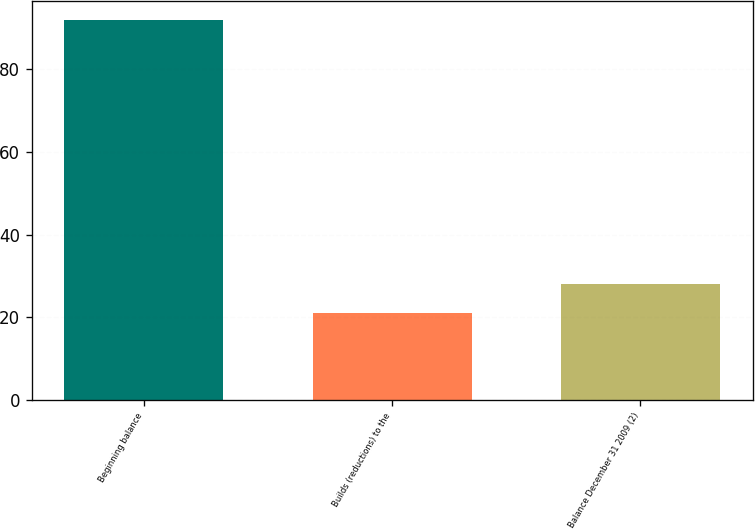<chart> <loc_0><loc_0><loc_500><loc_500><bar_chart><fcel>Beginning balance<fcel>Builds (reductions) to the<fcel>Balance December 31 2009 (2)<nl><fcel>92<fcel>21<fcel>28.1<nl></chart> 